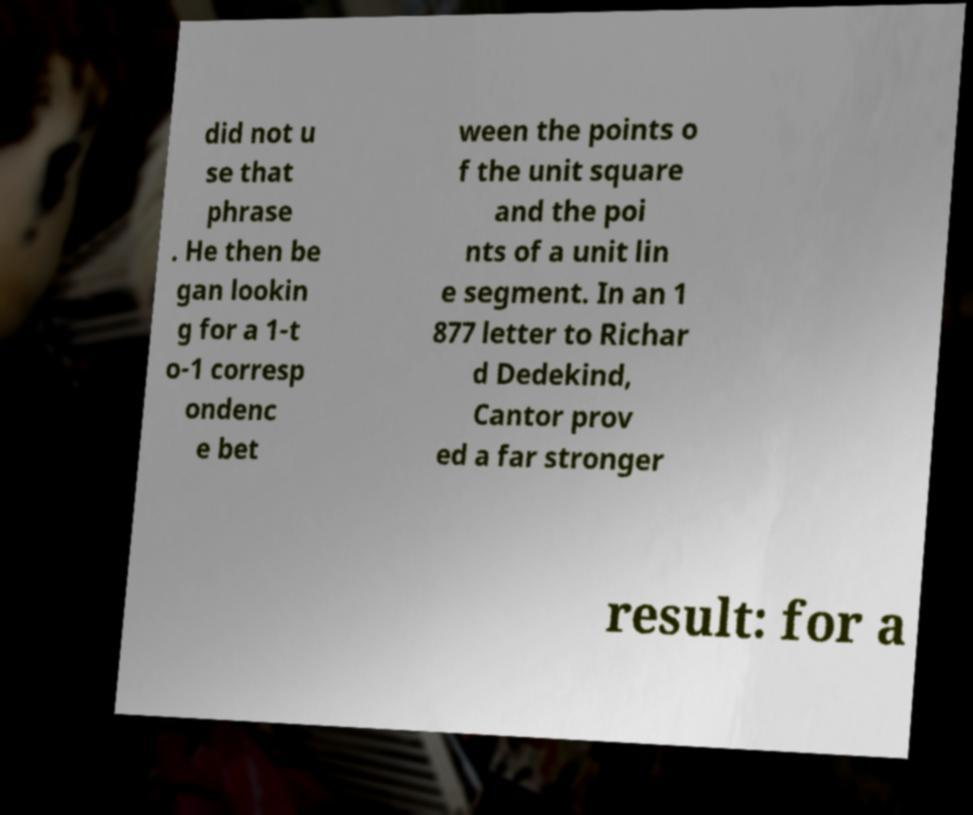For documentation purposes, I need the text within this image transcribed. Could you provide that? did not u se that phrase . He then be gan lookin g for a 1-t o-1 corresp ondenc e bet ween the points o f the unit square and the poi nts of a unit lin e segment. In an 1 877 letter to Richar d Dedekind, Cantor prov ed a far stronger result: for a 